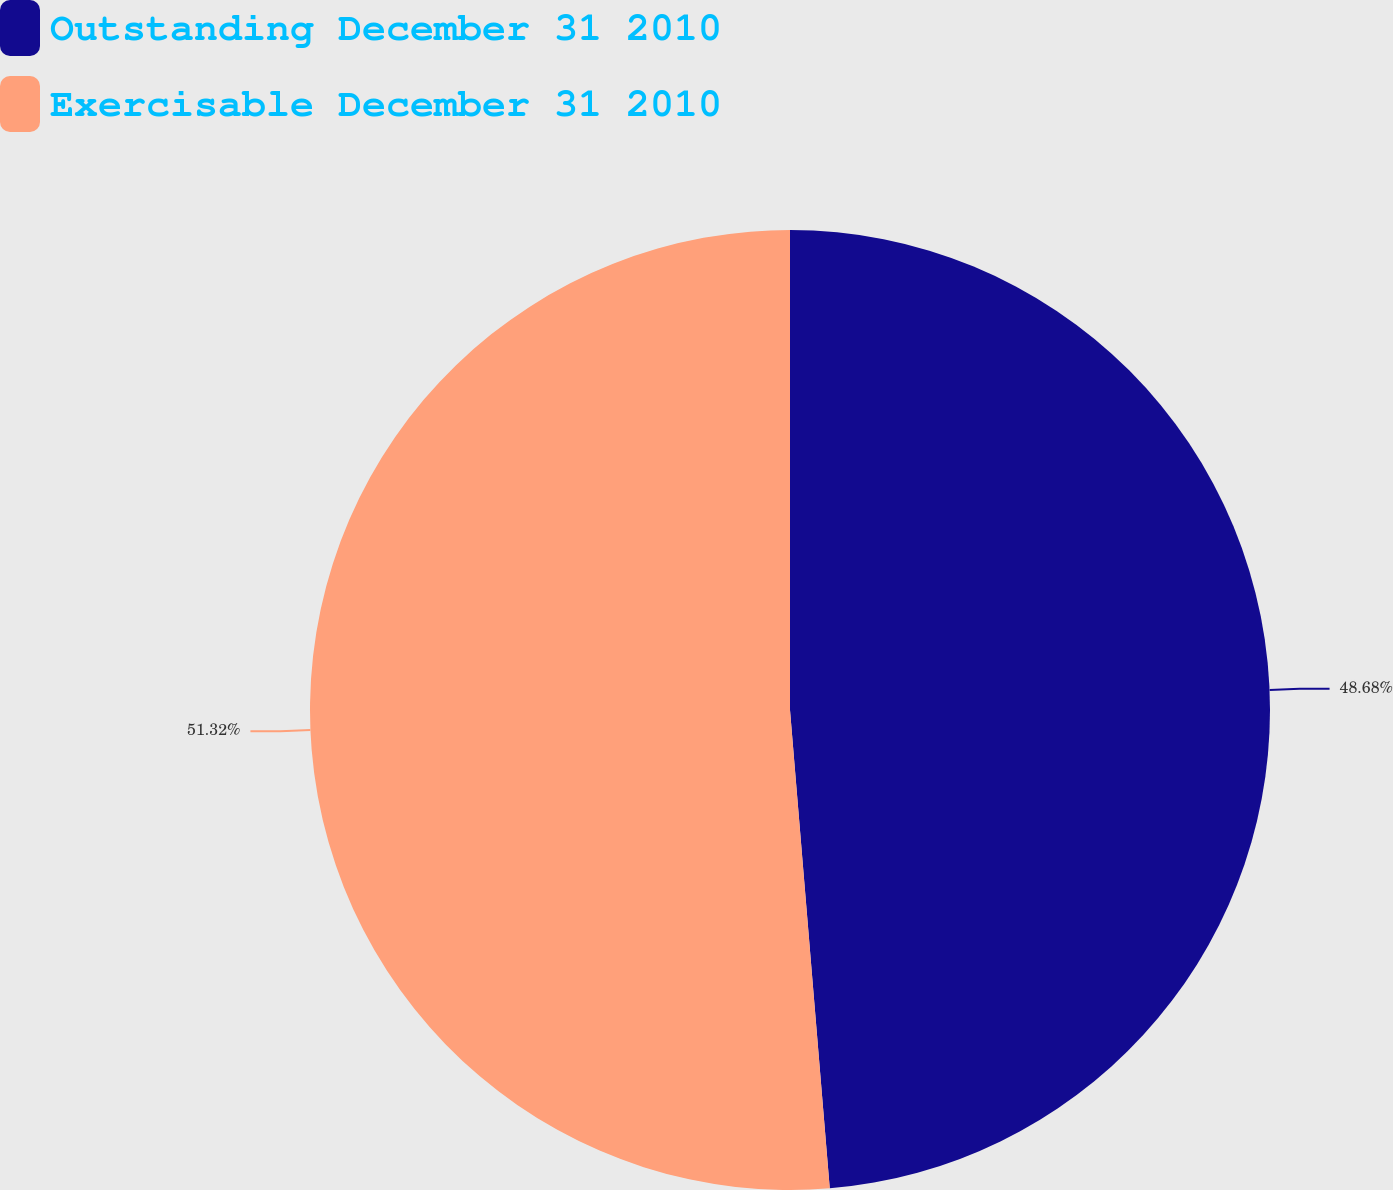Convert chart to OTSL. <chart><loc_0><loc_0><loc_500><loc_500><pie_chart><fcel>Outstanding December 31 2010<fcel>Exercisable December 31 2010<nl><fcel>48.68%<fcel>51.32%<nl></chart> 